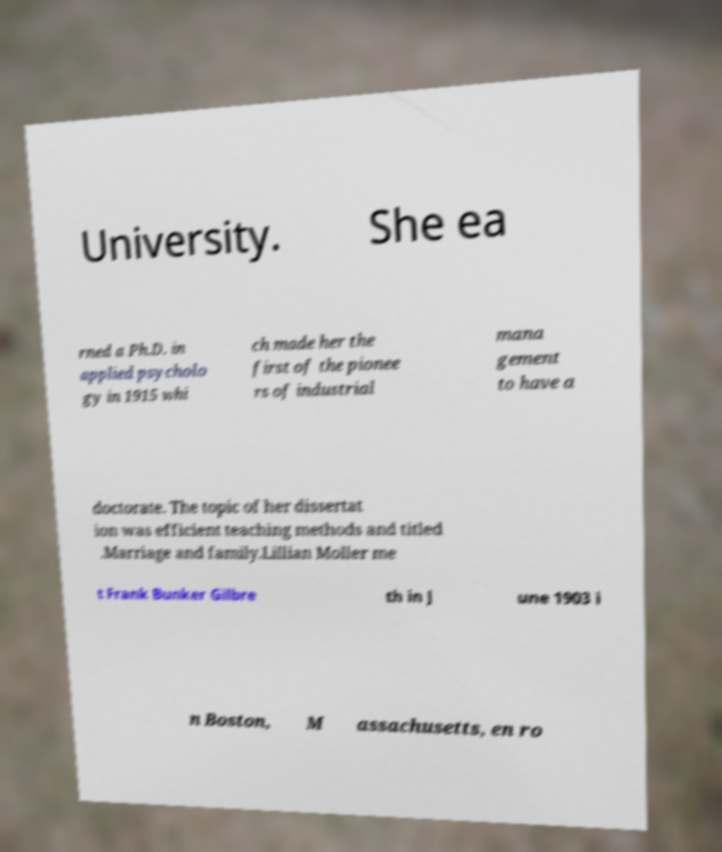What messages or text are displayed in this image? I need them in a readable, typed format. University. She ea rned a Ph.D. in applied psycholo gy in 1915 whi ch made her the first of the pionee rs of industrial mana gement to have a doctorate. The topic of her dissertat ion was efficient teaching methods and titled .Marriage and family.Lillian Moller me t Frank Bunker Gilbre th in J une 1903 i n Boston, M assachusetts, en ro 